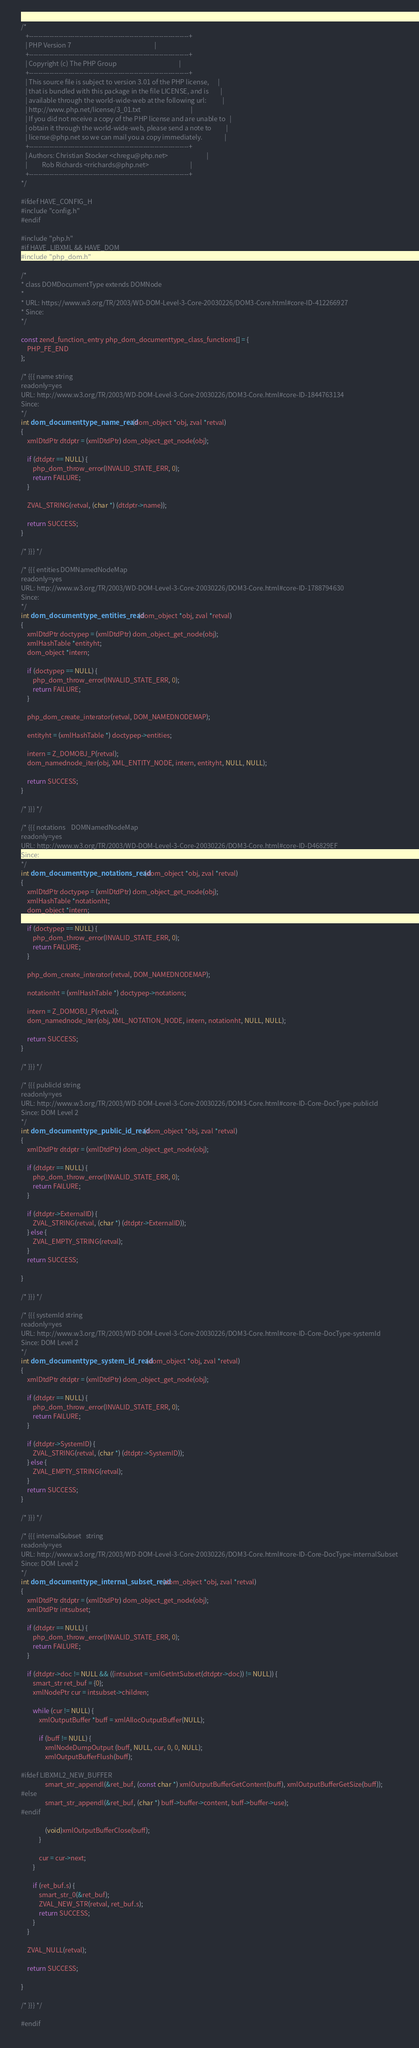Convert code to text. <code><loc_0><loc_0><loc_500><loc_500><_C_>/*
   +----------------------------------------------------------------------+
   | PHP Version 7                                                        |
   +----------------------------------------------------------------------+
   | Copyright (c) The PHP Group                                          |
   +----------------------------------------------------------------------+
   | This source file is subject to version 3.01 of the PHP license,      |
   | that is bundled with this package in the file LICENSE, and is        |
   | available through the world-wide-web at the following url:           |
   | http://www.php.net/license/3_01.txt                                  |
   | If you did not receive a copy of the PHP license and are unable to   |
   | obtain it through the world-wide-web, please send a note to          |
   | license@php.net so we can mail you a copy immediately.               |
   +----------------------------------------------------------------------+
   | Authors: Christian Stocker <chregu@php.net>                          |
   |          Rob Richards <rrichards@php.net>                            |
   +----------------------------------------------------------------------+
*/

#ifdef HAVE_CONFIG_H
#include "config.h"
#endif

#include "php.h"
#if HAVE_LIBXML && HAVE_DOM
#include "php_dom.h"

/*
* class DOMDocumentType extends DOMNode
*
* URL: https://www.w3.org/TR/2003/WD-DOM-Level-3-Core-20030226/DOM3-Core.html#core-ID-412266927
* Since:
*/

const zend_function_entry php_dom_documenttype_class_functions[] = {
	PHP_FE_END
};

/* {{{ name	string
readonly=yes
URL: http://www.w3.org/TR/2003/WD-DOM-Level-3-Core-20030226/DOM3-Core.html#core-ID-1844763134
Since:
*/
int dom_documenttype_name_read(dom_object *obj, zval *retval)
{
	xmlDtdPtr dtdptr = (xmlDtdPtr) dom_object_get_node(obj);

	if (dtdptr == NULL) {
		php_dom_throw_error(INVALID_STATE_ERR, 0);
		return FAILURE;
	}

	ZVAL_STRING(retval, (char *) (dtdptr->name));

	return SUCCESS;
}

/* }}} */

/* {{{ entities	DOMNamedNodeMap
readonly=yes
URL: http://www.w3.org/TR/2003/WD-DOM-Level-3-Core-20030226/DOM3-Core.html#core-ID-1788794630
Since:
*/
int dom_documenttype_entities_read(dom_object *obj, zval *retval)
{
	xmlDtdPtr doctypep = (xmlDtdPtr) dom_object_get_node(obj);
	xmlHashTable *entityht;
	dom_object *intern;

	if (doctypep == NULL) {
		php_dom_throw_error(INVALID_STATE_ERR, 0);
		return FAILURE;
	}

	php_dom_create_interator(retval, DOM_NAMEDNODEMAP);

	entityht = (xmlHashTable *) doctypep->entities;

	intern = Z_DOMOBJ_P(retval);
	dom_namednode_iter(obj, XML_ENTITY_NODE, intern, entityht, NULL, NULL);

	return SUCCESS;
}

/* }}} */

/* {{{ notations	DOMNamedNodeMap
readonly=yes
URL: http://www.w3.org/TR/2003/WD-DOM-Level-3-Core-20030226/DOM3-Core.html#core-ID-D46829EF
Since:
*/
int dom_documenttype_notations_read(dom_object *obj, zval *retval)
{
	xmlDtdPtr doctypep = (xmlDtdPtr) dom_object_get_node(obj);
	xmlHashTable *notationht;
	dom_object *intern;

	if (doctypep == NULL) {
		php_dom_throw_error(INVALID_STATE_ERR, 0);
		return FAILURE;
	}

	php_dom_create_interator(retval, DOM_NAMEDNODEMAP);

	notationht = (xmlHashTable *) doctypep->notations;

	intern = Z_DOMOBJ_P(retval);
	dom_namednode_iter(obj, XML_NOTATION_NODE, intern, notationht, NULL, NULL);

	return SUCCESS;
}

/* }}} */

/* {{{ publicId	string
readonly=yes
URL: http://www.w3.org/TR/2003/WD-DOM-Level-3-Core-20030226/DOM3-Core.html#core-ID-Core-DocType-publicId
Since: DOM Level 2
*/
int dom_documenttype_public_id_read(dom_object *obj, zval *retval)
{
	xmlDtdPtr dtdptr = (xmlDtdPtr) dom_object_get_node(obj);

	if (dtdptr == NULL) {
		php_dom_throw_error(INVALID_STATE_ERR, 0);
		return FAILURE;
	}

	if (dtdptr->ExternalID) {
		ZVAL_STRING(retval, (char *) (dtdptr->ExternalID));
	} else {
		ZVAL_EMPTY_STRING(retval);
	}
	return SUCCESS;

}

/* }}} */

/* {{{ systemId	string
readonly=yes
URL: http://www.w3.org/TR/2003/WD-DOM-Level-3-Core-20030226/DOM3-Core.html#core-ID-Core-DocType-systemId
Since: DOM Level 2
*/
int dom_documenttype_system_id_read(dom_object *obj, zval *retval)
{
	xmlDtdPtr dtdptr = (xmlDtdPtr) dom_object_get_node(obj);

	if (dtdptr == NULL) {
		php_dom_throw_error(INVALID_STATE_ERR, 0);
		return FAILURE;
	}

	if (dtdptr->SystemID) {
		ZVAL_STRING(retval, (char *) (dtdptr->SystemID));
	} else {
		ZVAL_EMPTY_STRING(retval);
	}
	return SUCCESS;
}

/* }}} */

/* {{{ internalSubset	string
readonly=yes
URL: http://www.w3.org/TR/2003/WD-DOM-Level-3-Core-20030226/DOM3-Core.html#core-ID-Core-DocType-internalSubset
Since: DOM Level 2
*/
int dom_documenttype_internal_subset_read(dom_object *obj, zval *retval)
{
	xmlDtdPtr dtdptr = (xmlDtdPtr) dom_object_get_node(obj);
	xmlDtdPtr intsubset;

	if (dtdptr == NULL) {
		php_dom_throw_error(INVALID_STATE_ERR, 0);
		return FAILURE;
	}

	if (dtdptr->doc != NULL && ((intsubset = xmlGetIntSubset(dtdptr->doc)) != NULL)) {
		smart_str ret_buf = {0};
		xmlNodePtr cur = intsubset->children;

		while (cur != NULL) {
			xmlOutputBuffer *buff = xmlAllocOutputBuffer(NULL);

			if (buff != NULL) {
				xmlNodeDumpOutput (buff, NULL, cur, 0, 0, NULL);
				xmlOutputBufferFlush(buff);

#ifdef LIBXML2_NEW_BUFFER
				smart_str_appendl(&ret_buf, (const char *) xmlOutputBufferGetContent(buff), xmlOutputBufferGetSize(buff));
#else
				smart_str_appendl(&ret_buf, (char *) buff->buffer->content, buff->buffer->use);
#endif

				(void)xmlOutputBufferClose(buff);
			}

			cur = cur->next;
		}

		if (ret_buf.s) {
			smart_str_0(&ret_buf);
			ZVAL_NEW_STR(retval, ret_buf.s);
			return SUCCESS;
		}
	}

	ZVAL_NULL(retval);

	return SUCCESS;

}

/* }}} */

#endif
</code> 